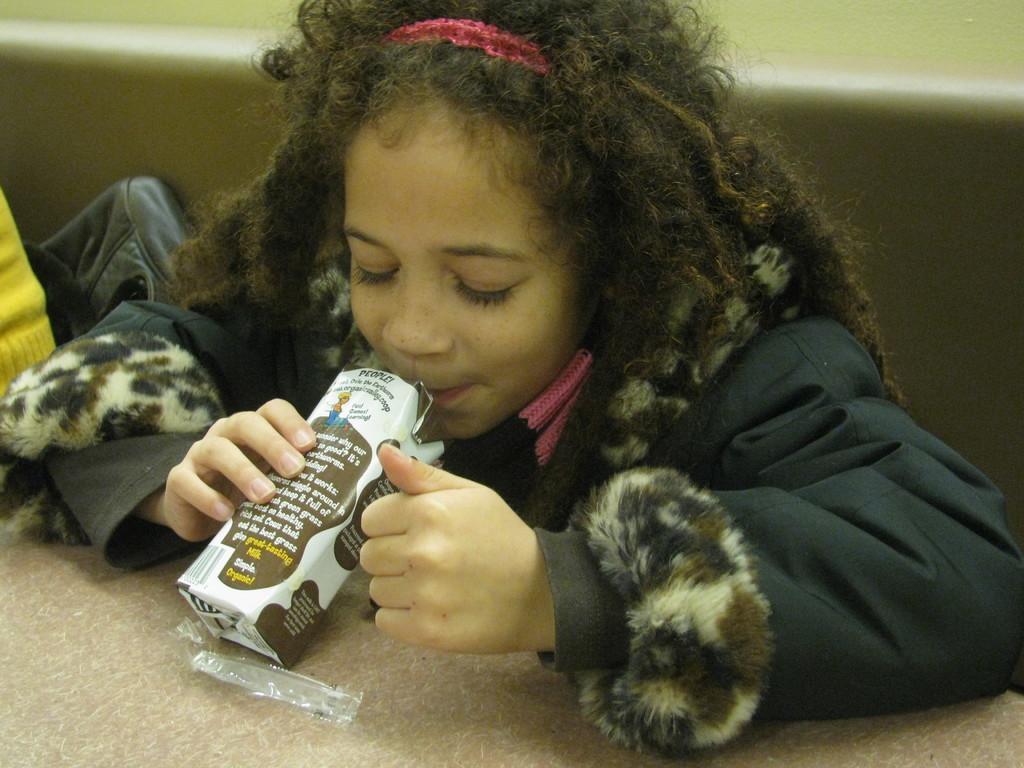Who is the main subject in the image? There is a girl in the middle of the image. What is the girl doing in the image? The girl is drinking. What object is located beside the girl? There is a bag beside the girl. What page is the girl reading in the image? There is no page or book visible in the image. 